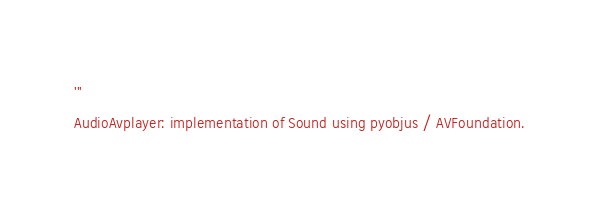<code> <loc_0><loc_0><loc_500><loc_500><_Python_>'''
AudioAvplayer: implementation of Sound using pyobjus / AVFoundation.</code> 